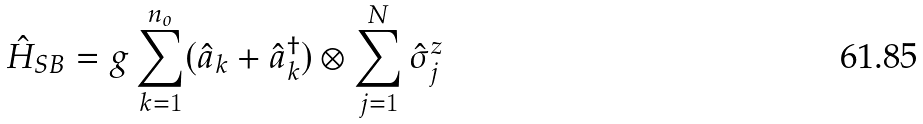Convert formula to latex. <formula><loc_0><loc_0><loc_500><loc_500>\hat { H } _ { S B } = g \sum ^ { n _ { o } } _ { k = 1 } ( \hat { a } _ { k } + \hat { a } ^ { \dag } _ { k } ) \otimes \sum ^ { N } _ { j = 1 } \hat { \sigma } ^ { z } _ { j }</formula> 